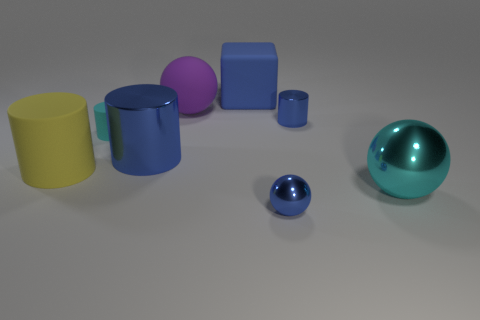Do the small blue metallic thing that is behind the tiny matte thing and the large purple rubber object have the same shape?
Provide a short and direct response. No. Is the number of tiny cylinders on the left side of the large matte block greater than the number of spheres behind the purple sphere?
Make the answer very short. Yes. What number of small purple blocks have the same material as the big blue cylinder?
Provide a succinct answer. 0. Is the blue matte cube the same size as the yellow object?
Your answer should be very brief. Yes. The big metal cylinder is what color?
Your answer should be compact. Blue. What number of things are large gray spheres or big purple matte things?
Offer a very short reply. 1. Is there a small blue shiny thing of the same shape as the blue matte object?
Your answer should be compact. No. Is the color of the shiny cylinder that is left of the large purple thing the same as the big block?
Keep it short and to the point. Yes. There is a tiny shiny thing that is behind the big metal thing that is right of the blue metal ball; what is its shape?
Ensure brevity in your answer.  Cylinder. Is there a metal cylinder of the same size as the blue ball?
Make the answer very short. Yes. 